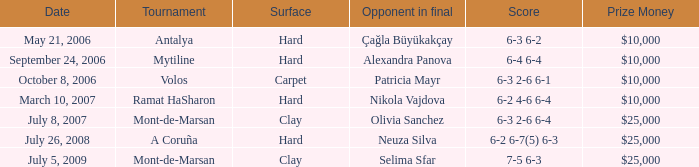What is the surface of the match on July 5, 2009? Clay. 